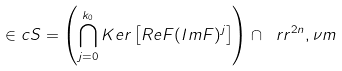Convert formula to latex. <formula><loc_0><loc_0><loc_500><loc_500>\in c S = \left ( \bigcap _ { j = 0 } ^ { k _ { 0 } } K e r \left [ R e F ( I m F ) ^ { j } \right ] \right ) \cap \ r r ^ { 2 n } , \nu m</formula> 